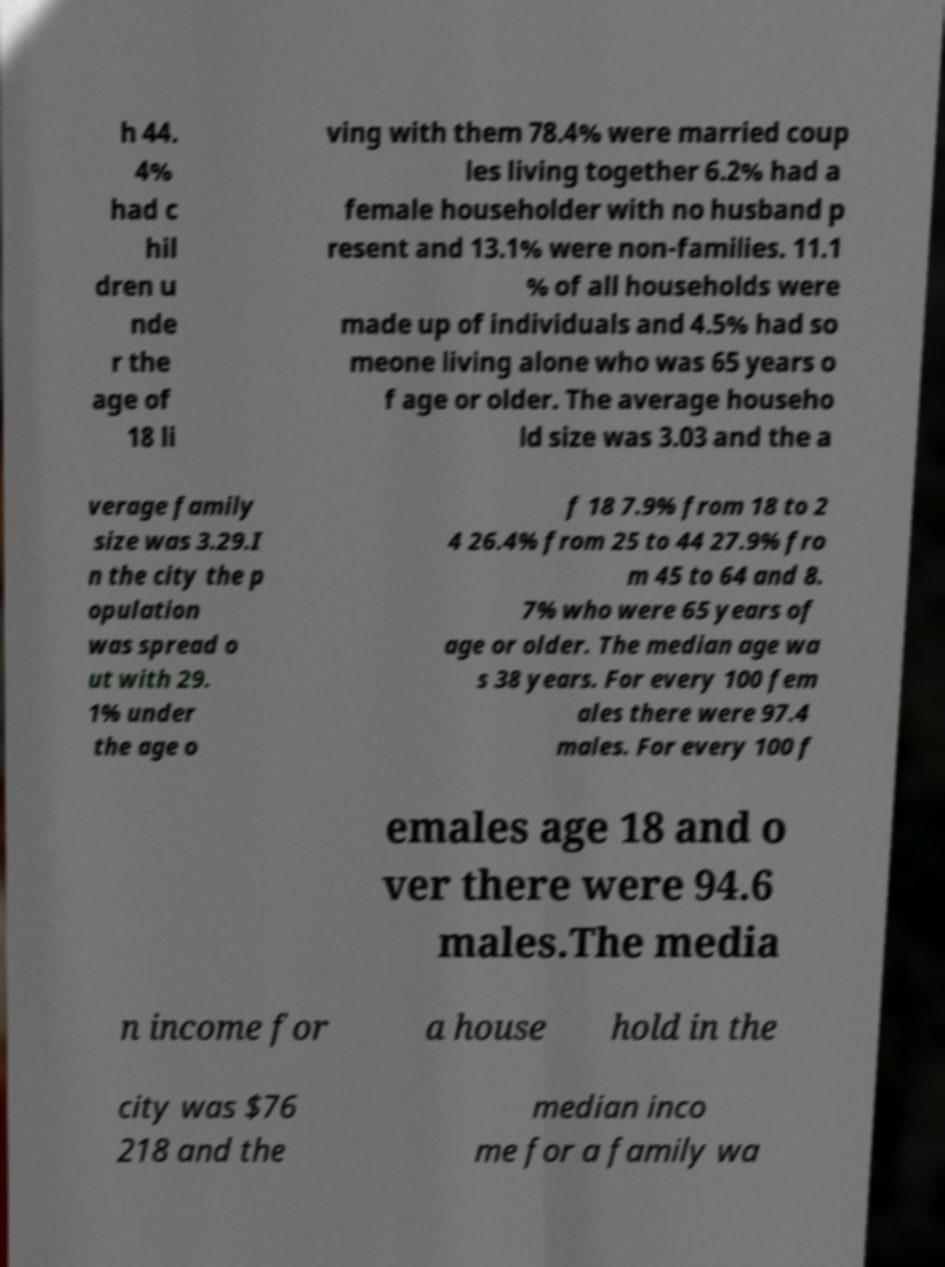Please identify and transcribe the text found in this image. h 44. 4% had c hil dren u nde r the age of 18 li ving with them 78.4% were married coup les living together 6.2% had a female householder with no husband p resent and 13.1% were non-families. 11.1 % of all households were made up of individuals and 4.5% had so meone living alone who was 65 years o f age or older. The average househo ld size was 3.03 and the a verage family size was 3.29.I n the city the p opulation was spread o ut with 29. 1% under the age o f 18 7.9% from 18 to 2 4 26.4% from 25 to 44 27.9% fro m 45 to 64 and 8. 7% who were 65 years of age or older. The median age wa s 38 years. For every 100 fem ales there were 97.4 males. For every 100 f emales age 18 and o ver there were 94.6 males.The media n income for a house hold in the city was $76 218 and the median inco me for a family wa 